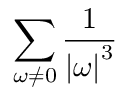<formula> <loc_0><loc_0><loc_500><loc_500>\sum _ { \omega \neq 0 } { \frac { 1 } { \left | \omega \right | ^ { 3 } } }</formula> 